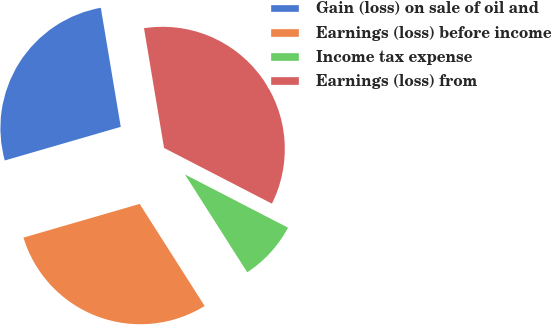<chart> <loc_0><loc_0><loc_500><loc_500><pie_chart><fcel>Gain (loss) on sale of oil and<fcel>Earnings (loss) before income<fcel>Income tax expense<fcel>Earnings (loss) from<nl><fcel>26.85%<fcel>29.53%<fcel>8.39%<fcel>35.23%<nl></chart> 